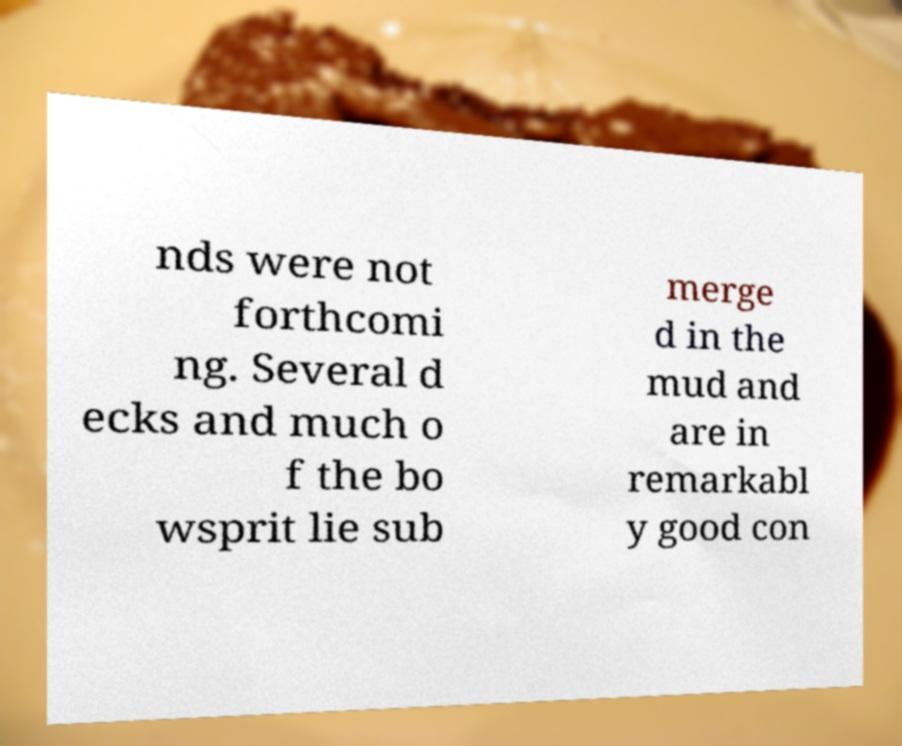I need the written content from this picture converted into text. Can you do that? nds were not forthcomi ng. Several d ecks and much o f the bo wsprit lie sub merge d in the mud and are in remarkabl y good con 